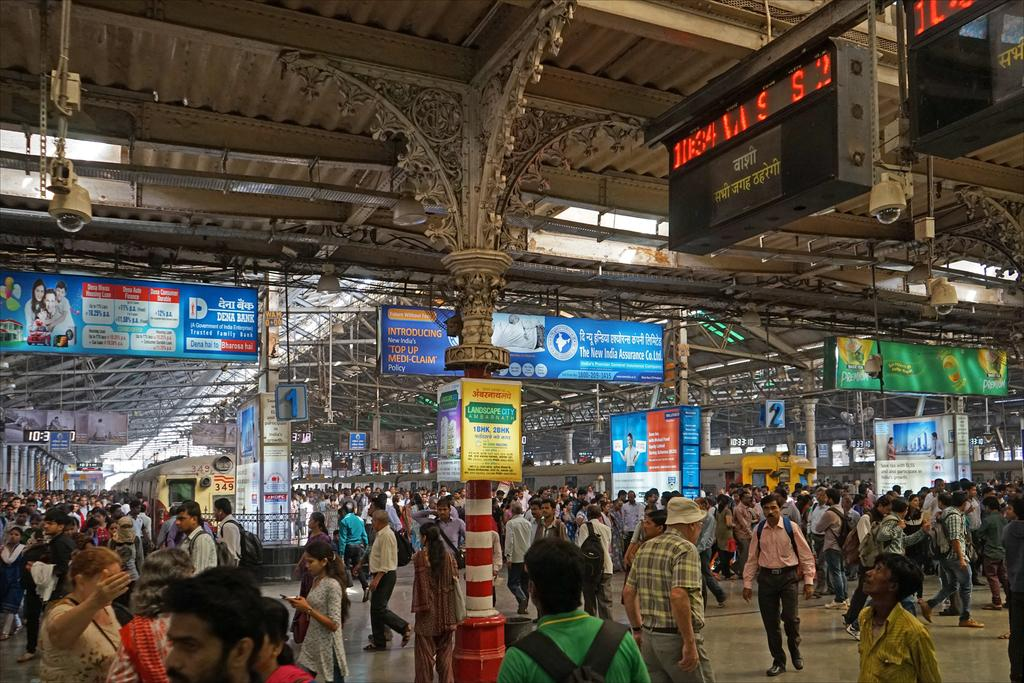How many people are in the image? There are persons in the image, but the exact number is not specified. What can be seen besides the persons in the image? There are two trains, hoardings with text, and a pillar in the image. What type of branch can be seen growing from the pillar in the image? There is no branch growing from the pillar in the image; only a pillar is mentioned. What is the desire of the persons in the image? The facts do not provide any information about the desires of the persons in the image, so it cannot be determined. 